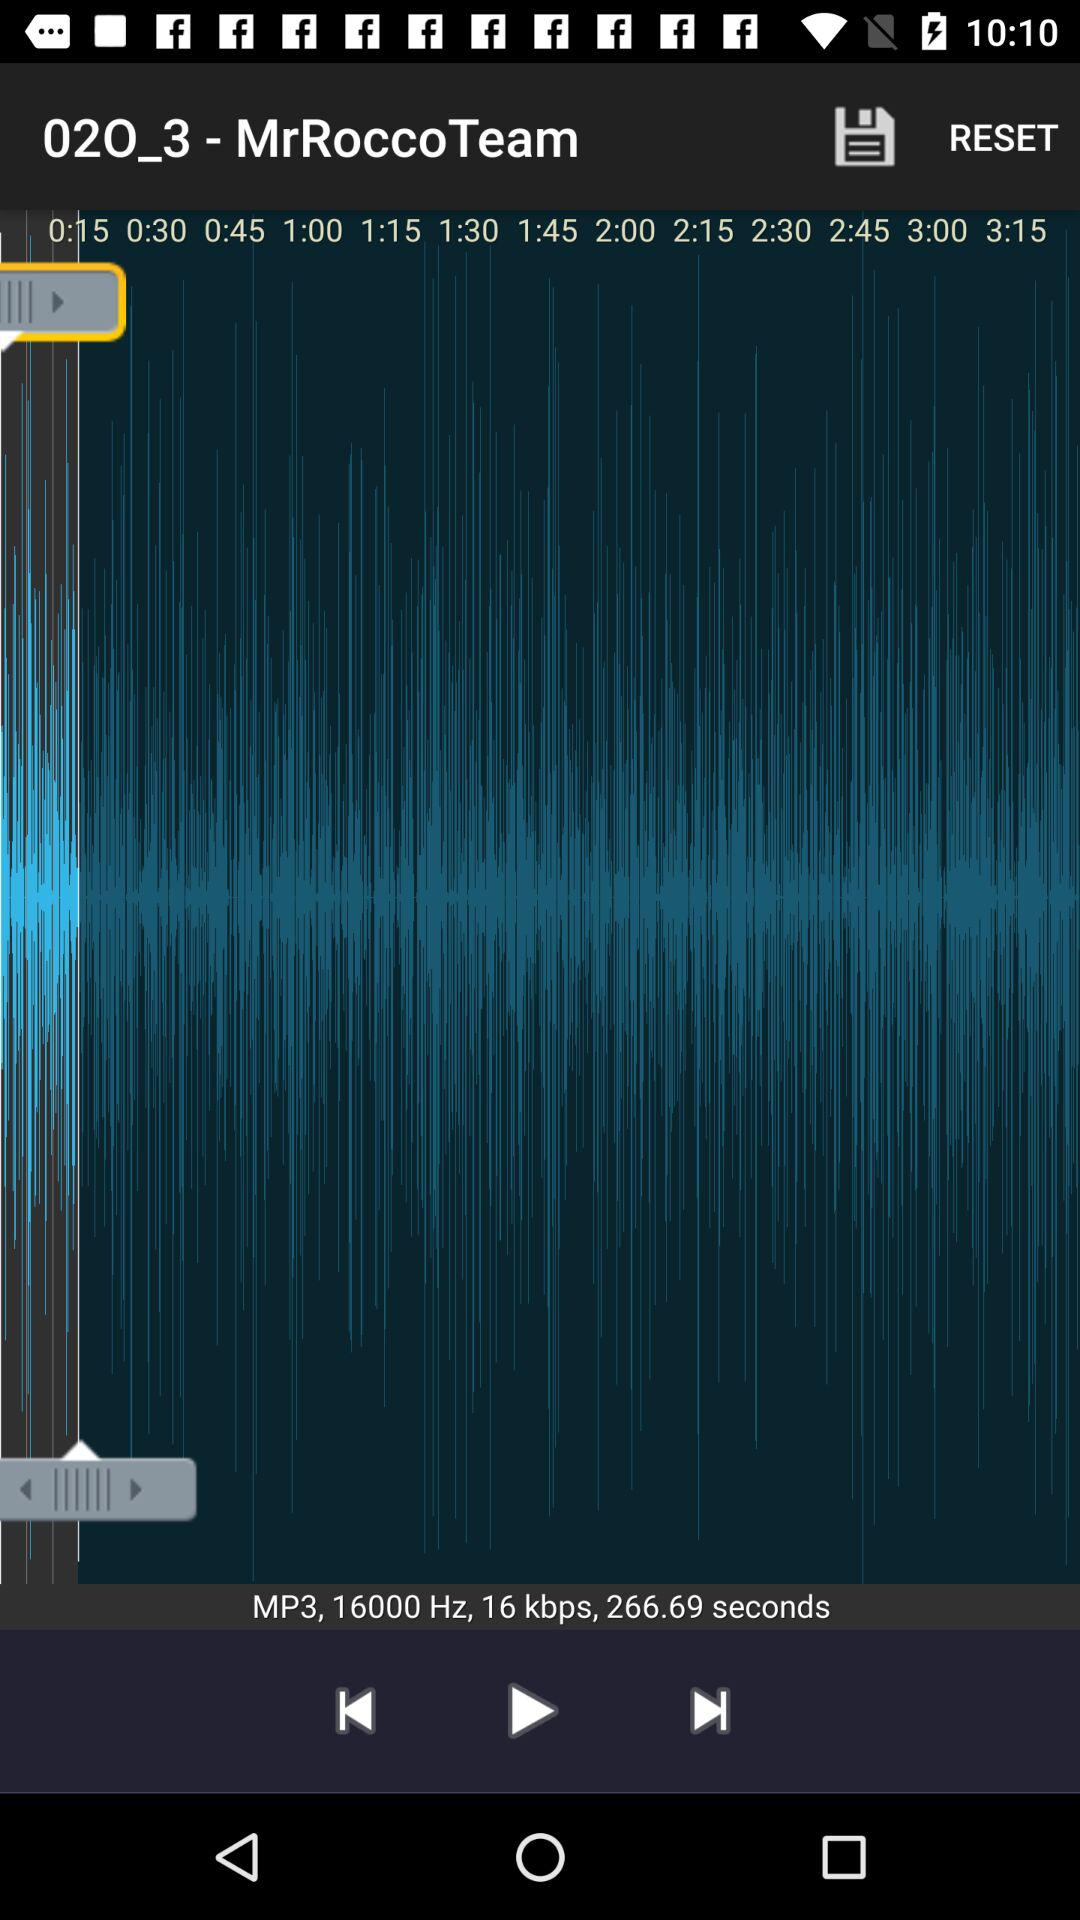What is the name of the audio? The name of the audio is "02O_3". 